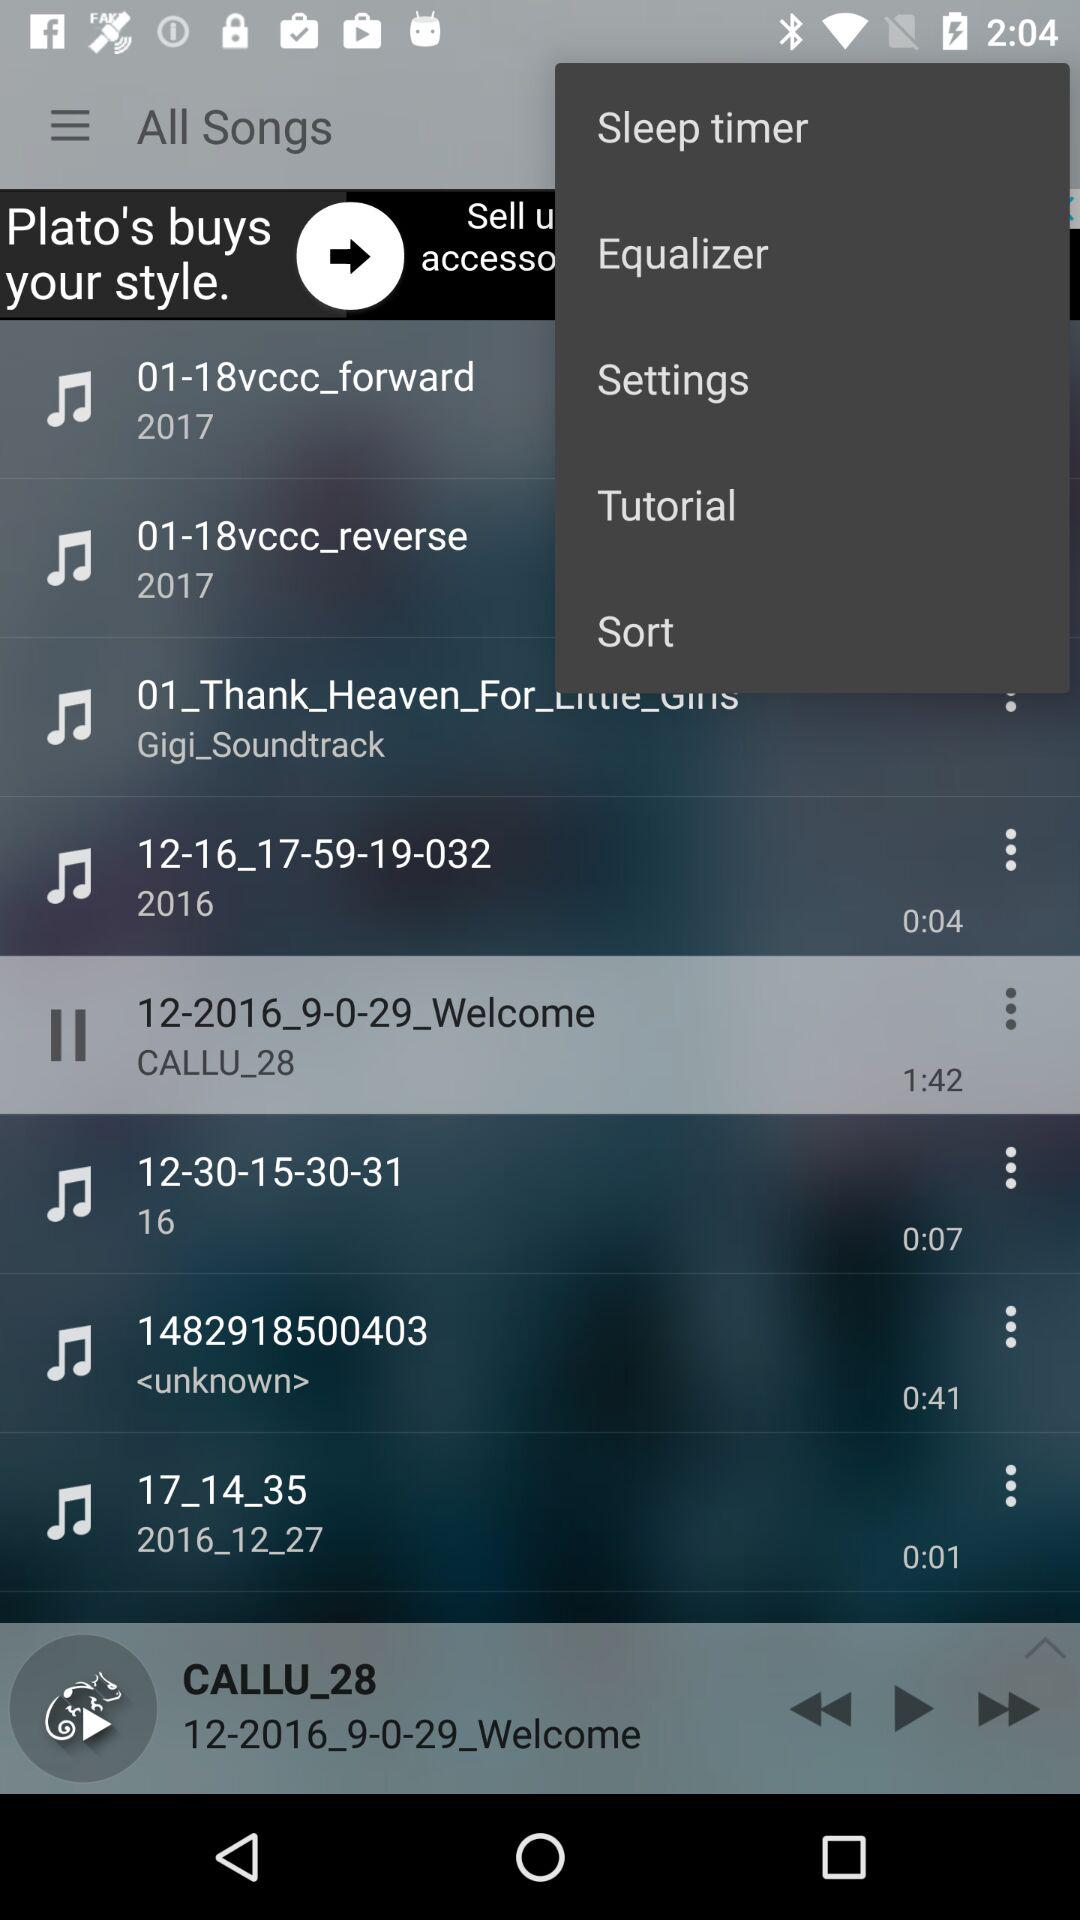What is the time duration of the "17_14_35" song? The time duration is 0:01 seconds. 